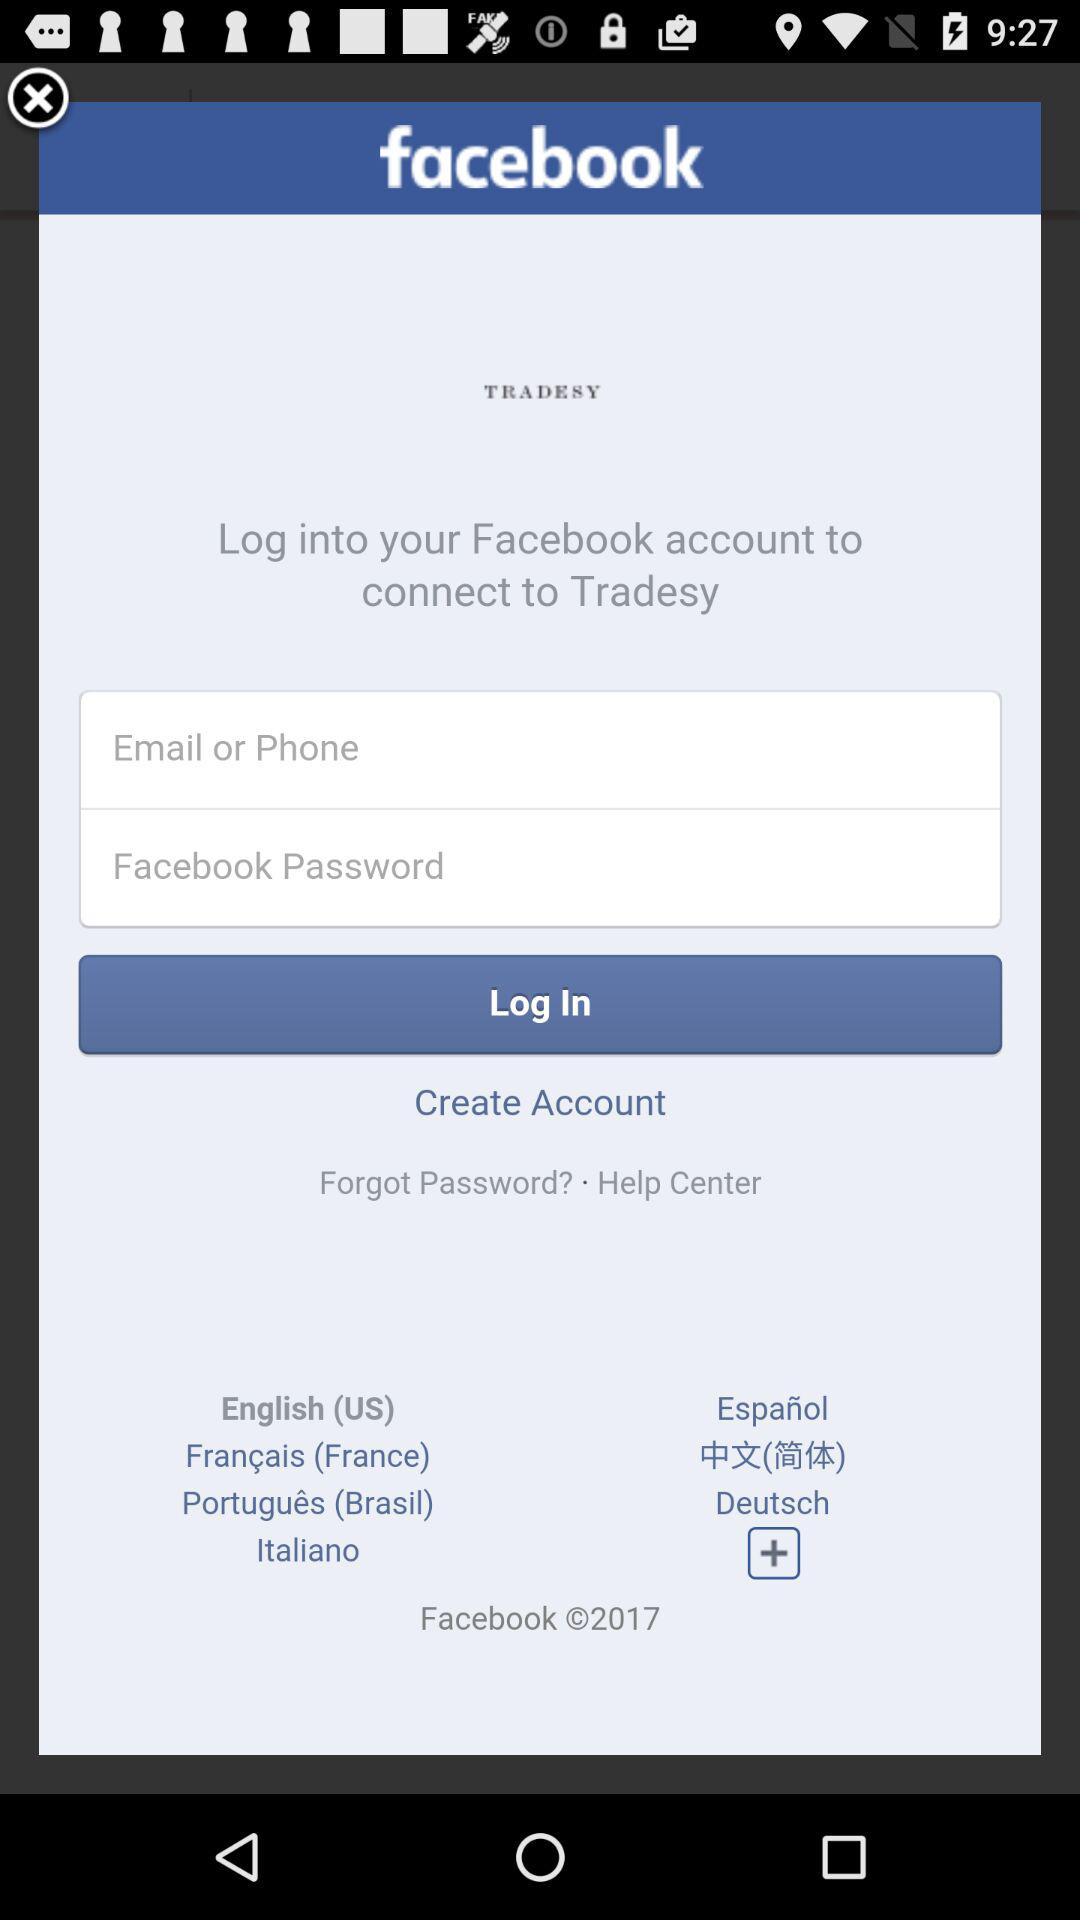How many text inputs are required to log in?
Answer the question using a single word or phrase. 2 